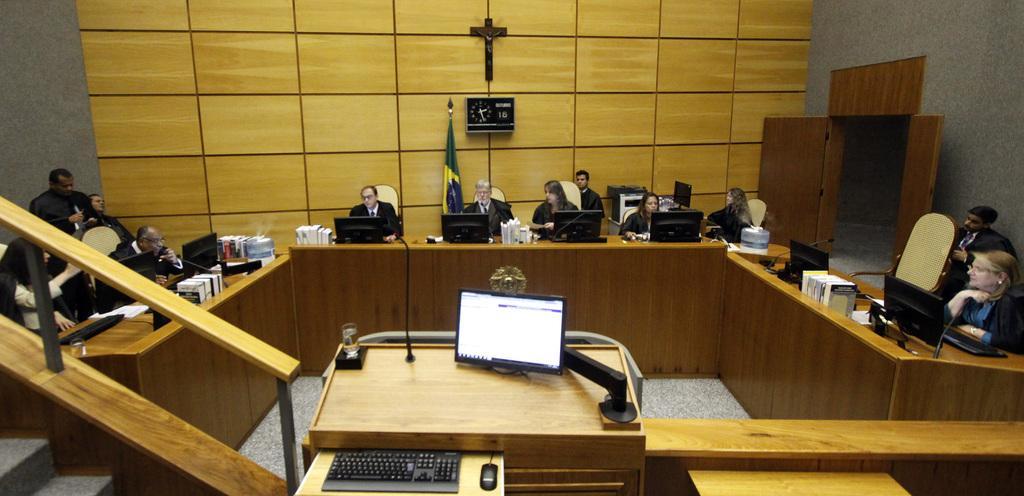Could you give a brief overview of what you see in this image? In this image there is a meeting hall. Many people are sitting on chair. There is a desk in front of them. On the desk there are desktops,books,bottle,keyboards. In the right side there is door. In the background there is a clock,there is a cross,There is a flag. In the foreground there is a podium,there is a monitor,keyboard,mouse and a mic. On the bottom left side there is a staircase. 